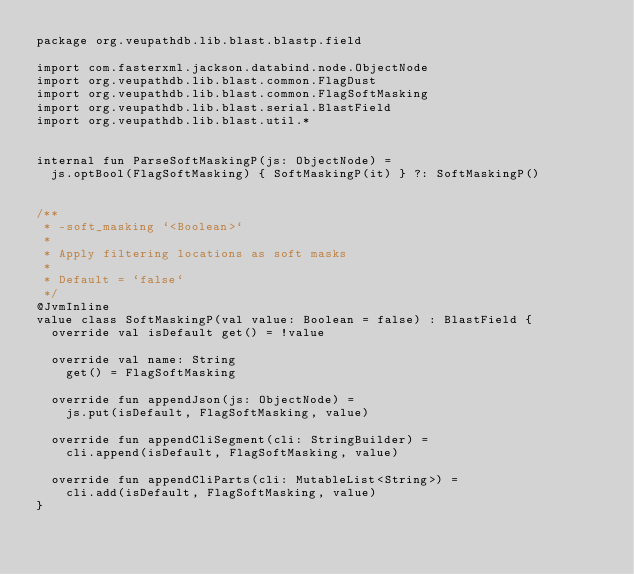Convert code to text. <code><loc_0><loc_0><loc_500><loc_500><_Kotlin_>package org.veupathdb.lib.blast.blastp.field

import com.fasterxml.jackson.databind.node.ObjectNode
import org.veupathdb.lib.blast.common.FlagDust
import org.veupathdb.lib.blast.common.FlagSoftMasking
import org.veupathdb.lib.blast.serial.BlastField
import org.veupathdb.lib.blast.util.*


internal fun ParseSoftMaskingP(js: ObjectNode) =
  js.optBool(FlagSoftMasking) { SoftMaskingP(it) } ?: SoftMaskingP()


/**
 * -soft_masking `<Boolean>`
 *
 * Apply filtering locations as soft masks
 *
 * Default = `false`
 */
@JvmInline
value class SoftMaskingP(val value: Boolean = false) : BlastField {
  override val isDefault get() = !value

  override val name: String
    get() = FlagSoftMasking

  override fun appendJson(js: ObjectNode) =
    js.put(isDefault, FlagSoftMasking, value)

  override fun appendCliSegment(cli: StringBuilder) =
    cli.append(isDefault, FlagSoftMasking, value)

  override fun appendCliParts(cli: MutableList<String>) =
    cli.add(isDefault, FlagSoftMasking, value)
}</code> 